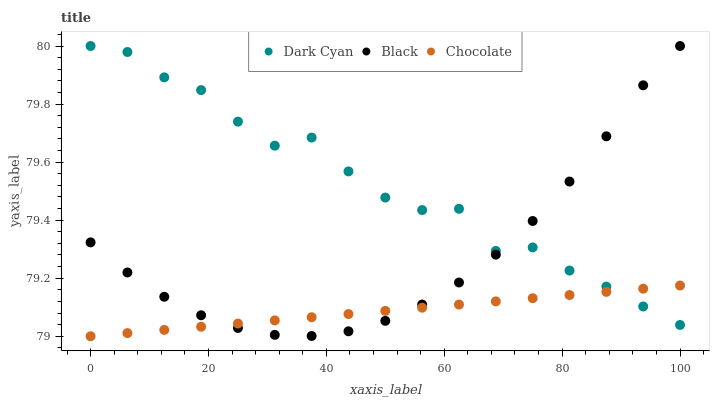Does Chocolate have the minimum area under the curve?
Answer yes or no. Yes. Does Dark Cyan have the maximum area under the curve?
Answer yes or no. Yes. Does Black have the minimum area under the curve?
Answer yes or no. No. Does Black have the maximum area under the curve?
Answer yes or no. No. Is Chocolate the smoothest?
Answer yes or no. Yes. Is Dark Cyan the roughest?
Answer yes or no. Yes. Is Black the smoothest?
Answer yes or no. No. Is Black the roughest?
Answer yes or no. No. Does Chocolate have the lowest value?
Answer yes or no. Yes. Does Black have the lowest value?
Answer yes or no. No. Does Black have the highest value?
Answer yes or no. Yes. Does Chocolate have the highest value?
Answer yes or no. No. Does Dark Cyan intersect Black?
Answer yes or no. Yes. Is Dark Cyan less than Black?
Answer yes or no. No. Is Dark Cyan greater than Black?
Answer yes or no. No. 